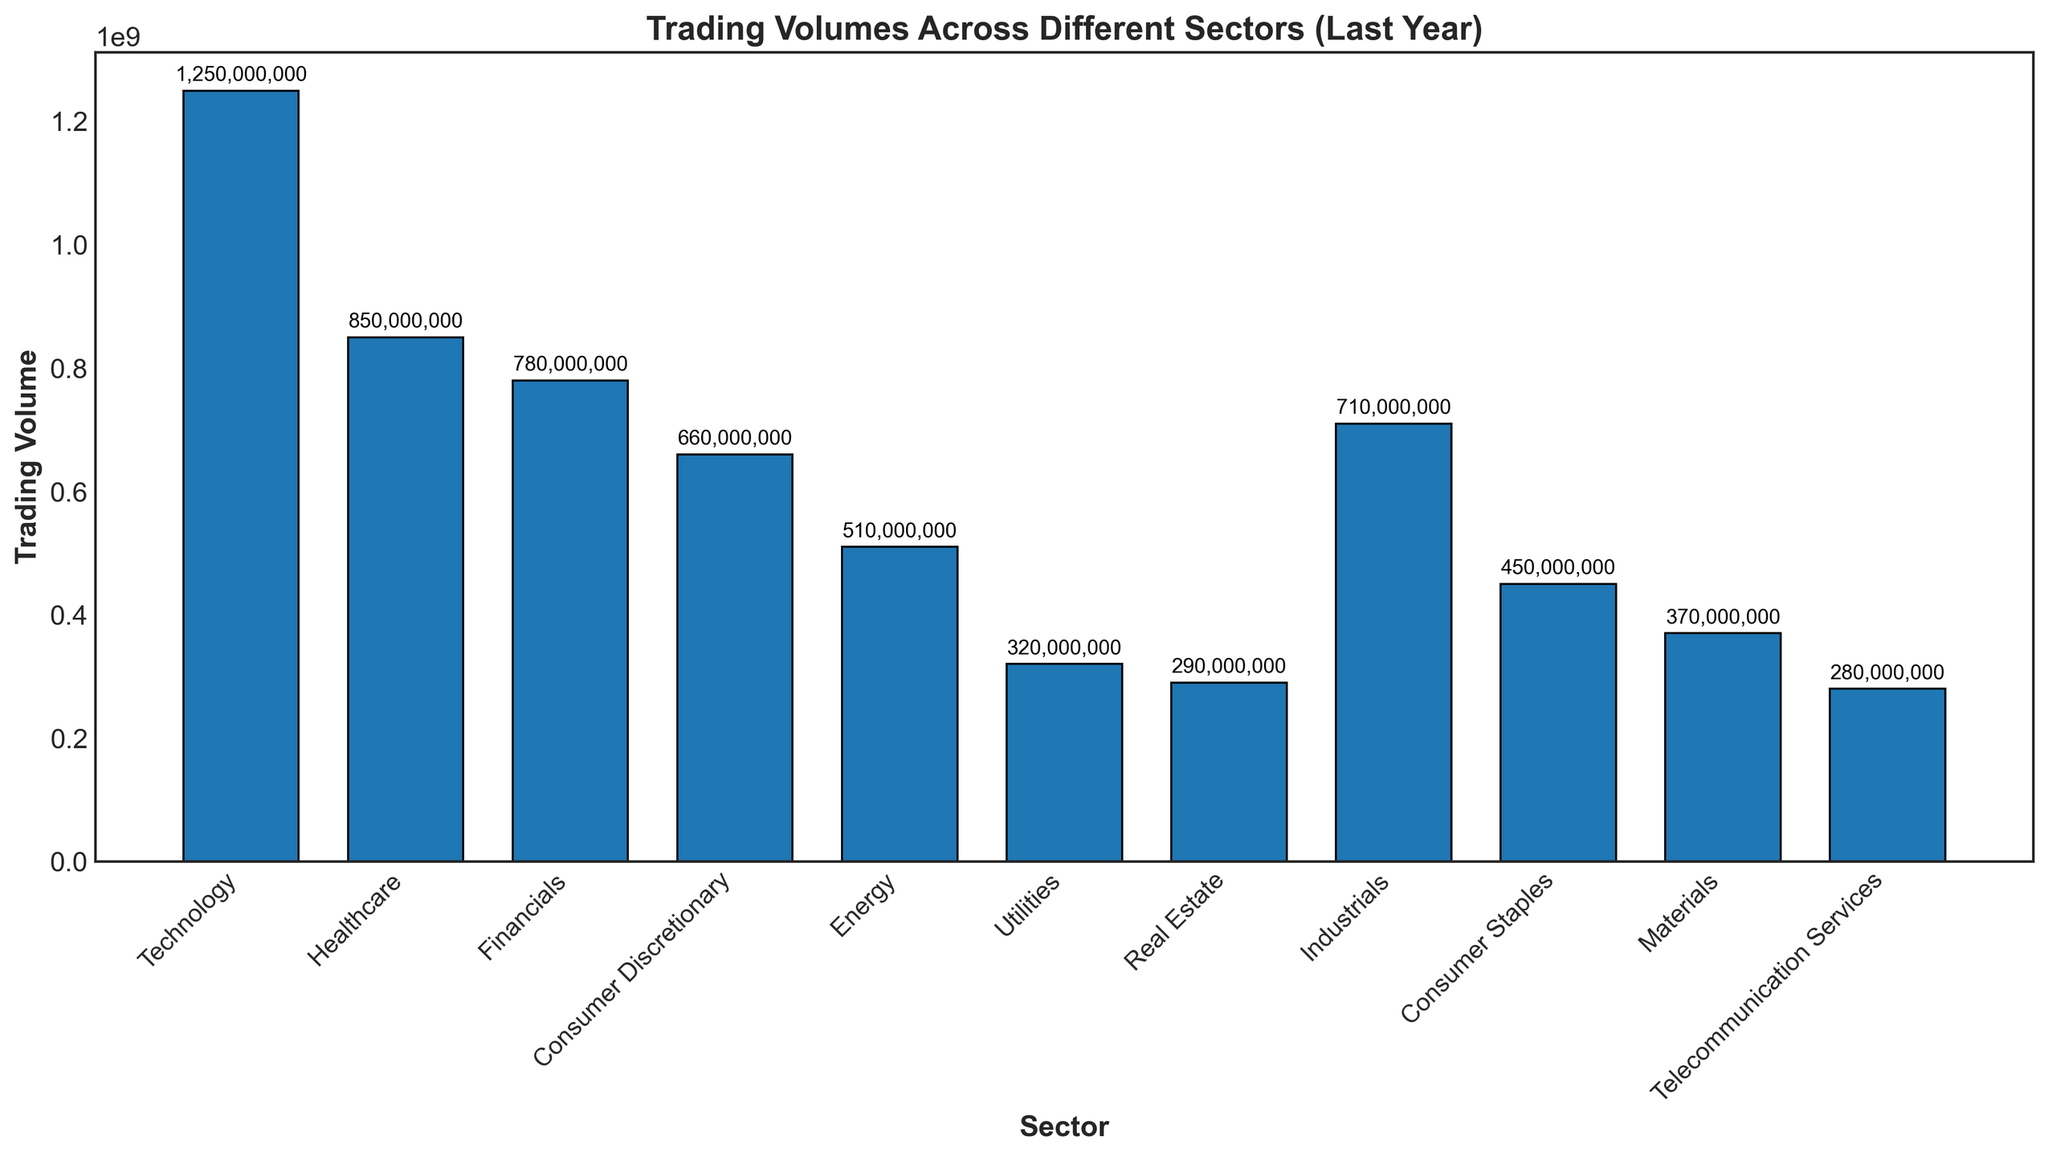Which sector has the highest trading volume? The sector with the highest bar represents the highest trading volume. By observing the chart, Technology has the tallest bar.
Answer: Technology What is the approximate difference in trading volume between the Technology and Healthcare sectors? The trading volume of Technology is 1,250,000,000, and Healthcare is 850,000,000. Subtracting these values gives 1,250,000,000 - 850,000,000.
Answer: 400,000,000 Which sectors have trading volumes greater than 700,000,000? By identifying bars higher than 700,000,000 on the chart, we find Technology, Healthcare, Financials, and Industrials.
Answer: Technology, Healthcare, Financials, Industrials What is the combined trading volume of Consumer Discretionary, Energy, and Utilities sectors? Adding their trading volumes: 660,000,000 (Consumer Discretionary) + 510,000,000 (Energy) + 320,000,000 (Utilities). The total is 1,490,000,000.
Answer: 1,490,000,000 Which sector has the lowest trading volume? The sector with the shortest bar represents the lowest trading volume. By observing the chart, Telecommunication Services has the shortest bar.
Answer: Telecommunication Services How much more is the total trading volume of Financials and Industrials compared to that of Energy and Utilities? Adding Financials (780,000,000) and Industrials (710,000,000) gives 1,490,000,000. Adding Energy (510,000,000) and Utilities (320,000,000) gives 830,000,000. The difference is 1,490,000,000 - 830,000,000.
Answer: 660,000,000 Which sector's trading volume is approximately half of Technology's trading volume? The trading volume of Technology is 1,250,000,000. Half of this volume is 625,000,000. Consumer Discretionary (660,000,000) is closest to 625,000,000.
Answer: Consumer Discretionary 